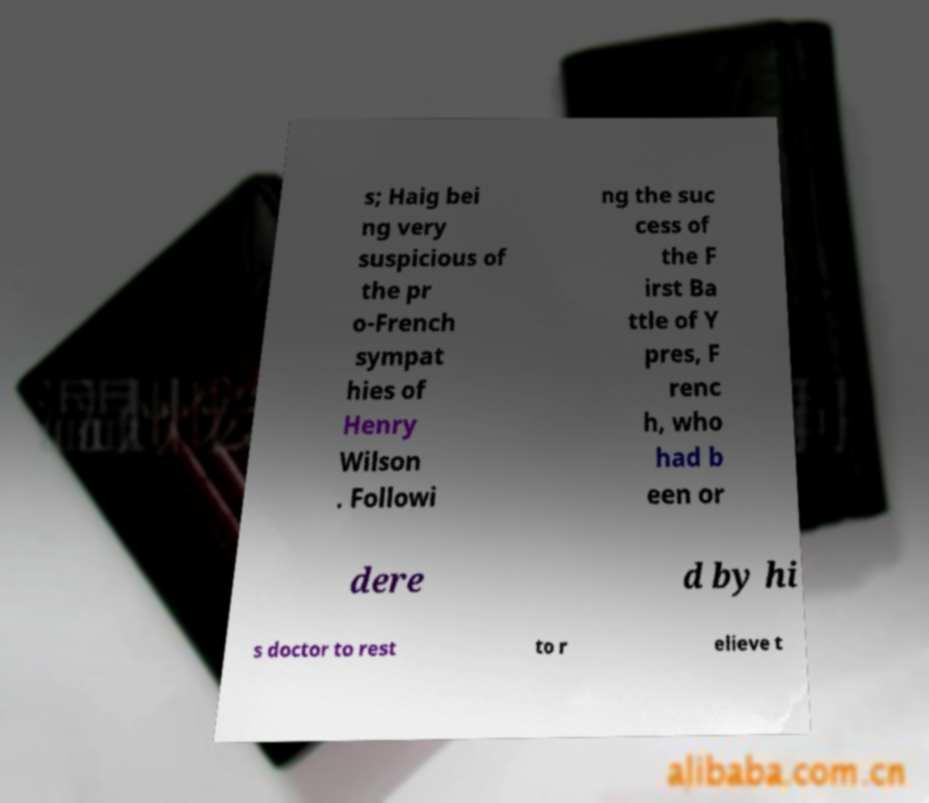Could you extract and type out the text from this image? s; Haig bei ng very suspicious of the pr o-French sympat hies of Henry Wilson . Followi ng the suc cess of the F irst Ba ttle of Y pres, F renc h, who had b een or dere d by hi s doctor to rest to r elieve t 